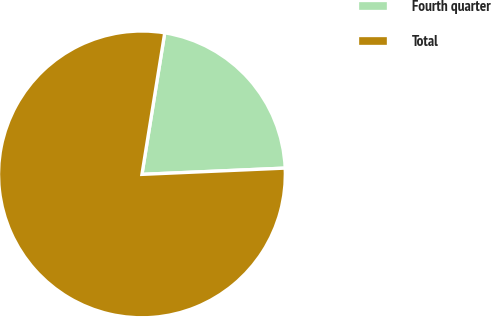Convert chart to OTSL. <chart><loc_0><loc_0><loc_500><loc_500><pie_chart><fcel>Fourth quarter<fcel>Total<nl><fcel>21.76%<fcel>78.24%<nl></chart> 